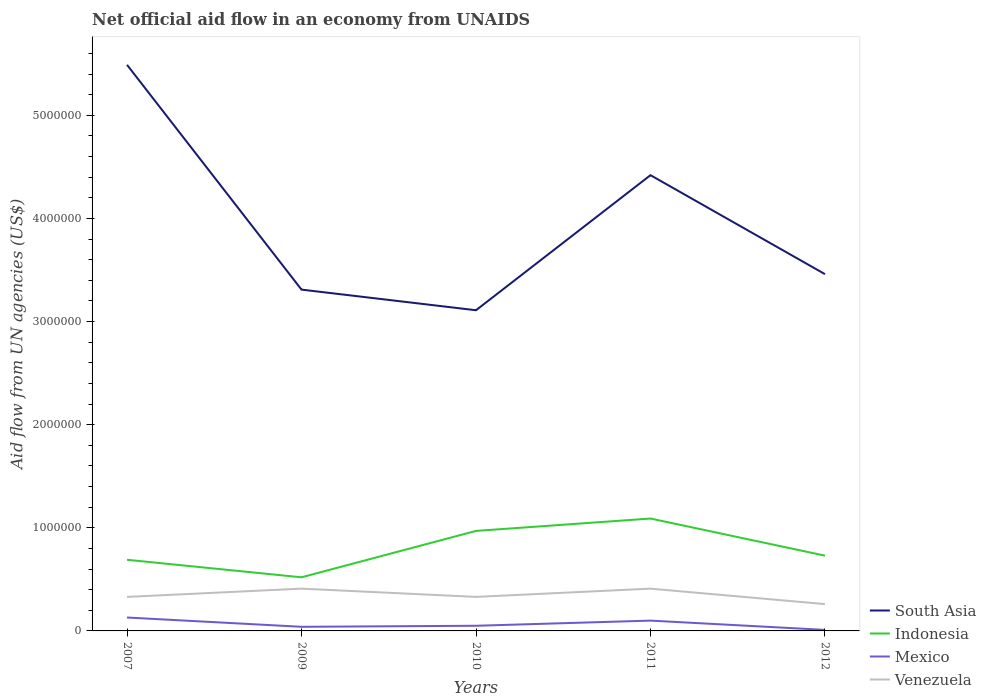How many different coloured lines are there?
Your response must be concise. 4. Is the number of lines equal to the number of legend labels?
Your response must be concise. Yes. Across all years, what is the maximum net official aid flow in Venezuela?
Your answer should be compact. 2.60e+05. In which year was the net official aid flow in South Asia maximum?
Your response must be concise. 2010. What is the difference between the highest and the second highest net official aid flow in South Asia?
Give a very brief answer. 2.38e+06. Is the net official aid flow in Indonesia strictly greater than the net official aid flow in South Asia over the years?
Give a very brief answer. Yes. How many lines are there?
Give a very brief answer. 4. What is the difference between two consecutive major ticks on the Y-axis?
Ensure brevity in your answer.  1.00e+06. Does the graph contain grids?
Offer a very short reply. No. How are the legend labels stacked?
Offer a very short reply. Vertical. What is the title of the graph?
Keep it short and to the point. Net official aid flow in an economy from UNAIDS. Does "Equatorial Guinea" appear as one of the legend labels in the graph?
Your answer should be compact. No. What is the label or title of the X-axis?
Ensure brevity in your answer.  Years. What is the label or title of the Y-axis?
Your answer should be compact. Aid flow from UN agencies (US$). What is the Aid flow from UN agencies (US$) in South Asia in 2007?
Offer a terse response. 5.49e+06. What is the Aid flow from UN agencies (US$) in Indonesia in 2007?
Make the answer very short. 6.90e+05. What is the Aid flow from UN agencies (US$) in Mexico in 2007?
Provide a succinct answer. 1.30e+05. What is the Aid flow from UN agencies (US$) of Venezuela in 2007?
Ensure brevity in your answer.  3.30e+05. What is the Aid flow from UN agencies (US$) in South Asia in 2009?
Make the answer very short. 3.31e+06. What is the Aid flow from UN agencies (US$) of Indonesia in 2009?
Offer a terse response. 5.20e+05. What is the Aid flow from UN agencies (US$) in South Asia in 2010?
Make the answer very short. 3.11e+06. What is the Aid flow from UN agencies (US$) of Indonesia in 2010?
Provide a short and direct response. 9.70e+05. What is the Aid flow from UN agencies (US$) in Mexico in 2010?
Provide a succinct answer. 5.00e+04. What is the Aid flow from UN agencies (US$) of South Asia in 2011?
Keep it short and to the point. 4.42e+06. What is the Aid flow from UN agencies (US$) of Indonesia in 2011?
Your answer should be very brief. 1.09e+06. What is the Aid flow from UN agencies (US$) of South Asia in 2012?
Ensure brevity in your answer.  3.46e+06. What is the Aid flow from UN agencies (US$) of Indonesia in 2012?
Ensure brevity in your answer.  7.30e+05. Across all years, what is the maximum Aid flow from UN agencies (US$) of South Asia?
Your answer should be very brief. 5.49e+06. Across all years, what is the maximum Aid flow from UN agencies (US$) of Indonesia?
Your response must be concise. 1.09e+06. Across all years, what is the maximum Aid flow from UN agencies (US$) of Mexico?
Provide a succinct answer. 1.30e+05. Across all years, what is the minimum Aid flow from UN agencies (US$) of South Asia?
Give a very brief answer. 3.11e+06. Across all years, what is the minimum Aid flow from UN agencies (US$) in Indonesia?
Make the answer very short. 5.20e+05. Across all years, what is the minimum Aid flow from UN agencies (US$) of Venezuela?
Ensure brevity in your answer.  2.60e+05. What is the total Aid flow from UN agencies (US$) of South Asia in the graph?
Your answer should be very brief. 1.98e+07. What is the total Aid flow from UN agencies (US$) in Venezuela in the graph?
Your answer should be compact. 1.74e+06. What is the difference between the Aid flow from UN agencies (US$) of South Asia in 2007 and that in 2009?
Keep it short and to the point. 2.18e+06. What is the difference between the Aid flow from UN agencies (US$) of Indonesia in 2007 and that in 2009?
Give a very brief answer. 1.70e+05. What is the difference between the Aid flow from UN agencies (US$) in Venezuela in 2007 and that in 2009?
Make the answer very short. -8.00e+04. What is the difference between the Aid flow from UN agencies (US$) of South Asia in 2007 and that in 2010?
Your answer should be very brief. 2.38e+06. What is the difference between the Aid flow from UN agencies (US$) in Indonesia in 2007 and that in 2010?
Make the answer very short. -2.80e+05. What is the difference between the Aid flow from UN agencies (US$) of Mexico in 2007 and that in 2010?
Ensure brevity in your answer.  8.00e+04. What is the difference between the Aid flow from UN agencies (US$) in Venezuela in 2007 and that in 2010?
Ensure brevity in your answer.  0. What is the difference between the Aid flow from UN agencies (US$) of South Asia in 2007 and that in 2011?
Your answer should be compact. 1.07e+06. What is the difference between the Aid flow from UN agencies (US$) in Indonesia in 2007 and that in 2011?
Your response must be concise. -4.00e+05. What is the difference between the Aid flow from UN agencies (US$) of Mexico in 2007 and that in 2011?
Give a very brief answer. 3.00e+04. What is the difference between the Aid flow from UN agencies (US$) of South Asia in 2007 and that in 2012?
Offer a very short reply. 2.03e+06. What is the difference between the Aid flow from UN agencies (US$) of Mexico in 2007 and that in 2012?
Offer a terse response. 1.20e+05. What is the difference between the Aid flow from UN agencies (US$) in Venezuela in 2007 and that in 2012?
Make the answer very short. 7.00e+04. What is the difference between the Aid flow from UN agencies (US$) in Indonesia in 2009 and that in 2010?
Give a very brief answer. -4.50e+05. What is the difference between the Aid flow from UN agencies (US$) of South Asia in 2009 and that in 2011?
Ensure brevity in your answer.  -1.11e+06. What is the difference between the Aid flow from UN agencies (US$) of Indonesia in 2009 and that in 2011?
Your answer should be very brief. -5.70e+05. What is the difference between the Aid flow from UN agencies (US$) in Mexico in 2009 and that in 2011?
Your answer should be compact. -6.00e+04. What is the difference between the Aid flow from UN agencies (US$) of Indonesia in 2009 and that in 2012?
Keep it short and to the point. -2.10e+05. What is the difference between the Aid flow from UN agencies (US$) in Mexico in 2009 and that in 2012?
Offer a very short reply. 3.00e+04. What is the difference between the Aid flow from UN agencies (US$) of Venezuela in 2009 and that in 2012?
Your response must be concise. 1.50e+05. What is the difference between the Aid flow from UN agencies (US$) in South Asia in 2010 and that in 2011?
Your response must be concise. -1.31e+06. What is the difference between the Aid flow from UN agencies (US$) in South Asia in 2010 and that in 2012?
Your answer should be very brief. -3.50e+05. What is the difference between the Aid flow from UN agencies (US$) in Indonesia in 2010 and that in 2012?
Your response must be concise. 2.40e+05. What is the difference between the Aid flow from UN agencies (US$) in Mexico in 2010 and that in 2012?
Provide a succinct answer. 4.00e+04. What is the difference between the Aid flow from UN agencies (US$) of South Asia in 2011 and that in 2012?
Offer a terse response. 9.60e+05. What is the difference between the Aid flow from UN agencies (US$) in Indonesia in 2011 and that in 2012?
Your response must be concise. 3.60e+05. What is the difference between the Aid flow from UN agencies (US$) in Mexico in 2011 and that in 2012?
Provide a succinct answer. 9.00e+04. What is the difference between the Aid flow from UN agencies (US$) of South Asia in 2007 and the Aid flow from UN agencies (US$) of Indonesia in 2009?
Your answer should be compact. 4.97e+06. What is the difference between the Aid flow from UN agencies (US$) of South Asia in 2007 and the Aid flow from UN agencies (US$) of Mexico in 2009?
Provide a succinct answer. 5.45e+06. What is the difference between the Aid flow from UN agencies (US$) of South Asia in 2007 and the Aid flow from UN agencies (US$) of Venezuela in 2009?
Ensure brevity in your answer.  5.08e+06. What is the difference between the Aid flow from UN agencies (US$) of Indonesia in 2007 and the Aid flow from UN agencies (US$) of Mexico in 2009?
Offer a very short reply. 6.50e+05. What is the difference between the Aid flow from UN agencies (US$) of Mexico in 2007 and the Aid flow from UN agencies (US$) of Venezuela in 2009?
Offer a very short reply. -2.80e+05. What is the difference between the Aid flow from UN agencies (US$) of South Asia in 2007 and the Aid flow from UN agencies (US$) of Indonesia in 2010?
Provide a short and direct response. 4.52e+06. What is the difference between the Aid flow from UN agencies (US$) in South Asia in 2007 and the Aid flow from UN agencies (US$) in Mexico in 2010?
Your answer should be compact. 5.44e+06. What is the difference between the Aid flow from UN agencies (US$) in South Asia in 2007 and the Aid flow from UN agencies (US$) in Venezuela in 2010?
Give a very brief answer. 5.16e+06. What is the difference between the Aid flow from UN agencies (US$) in Indonesia in 2007 and the Aid flow from UN agencies (US$) in Mexico in 2010?
Offer a terse response. 6.40e+05. What is the difference between the Aid flow from UN agencies (US$) of Mexico in 2007 and the Aid flow from UN agencies (US$) of Venezuela in 2010?
Offer a very short reply. -2.00e+05. What is the difference between the Aid flow from UN agencies (US$) in South Asia in 2007 and the Aid flow from UN agencies (US$) in Indonesia in 2011?
Ensure brevity in your answer.  4.40e+06. What is the difference between the Aid flow from UN agencies (US$) in South Asia in 2007 and the Aid flow from UN agencies (US$) in Mexico in 2011?
Ensure brevity in your answer.  5.39e+06. What is the difference between the Aid flow from UN agencies (US$) in South Asia in 2007 and the Aid flow from UN agencies (US$) in Venezuela in 2011?
Your response must be concise. 5.08e+06. What is the difference between the Aid flow from UN agencies (US$) in Indonesia in 2007 and the Aid flow from UN agencies (US$) in Mexico in 2011?
Keep it short and to the point. 5.90e+05. What is the difference between the Aid flow from UN agencies (US$) in Indonesia in 2007 and the Aid flow from UN agencies (US$) in Venezuela in 2011?
Offer a very short reply. 2.80e+05. What is the difference between the Aid flow from UN agencies (US$) of Mexico in 2007 and the Aid flow from UN agencies (US$) of Venezuela in 2011?
Make the answer very short. -2.80e+05. What is the difference between the Aid flow from UN agencies (US$) in South Asia in 2007 and the Aid flow from UN agencies (US$) in Indonesia in 2012?
Give a very brief answer. 4.76e+06. What is the difference between the Aid flow from UN agencies (US$) in South Asia in 2007 and the Aid flow from UN agencies (US$) in Mexico in 2012?
Keep it short and to the point. 5.48e+06. What is the difference between the Aid flow from UN agencies (US$) of South Asia in 2007 and the Aid flow from UN agencies (US$) of Venezuela in 2012?
Keep it short and to the point. 5.23e+06. What is the difference between the Aid flow from UN agencies (US$) in Indonesia in 2007 and the Aid flow from UN agencies (US$) in Mexico in 2012?
Keep it short and to the point. 6.80e+05. What is the difference between the Aid flow from UN agencies (US$) of Indonesia in 2007 and the Aid flow from UN agencies (US$) of Venezuela in 2012?
Your answer should be very brief. 4.30e+05. What is the difference between the Aid flow from UN agencies (US$) of Mexico in 2007 and the Aid flow from UN agencies (US$) of Venezuela in 2012?
Make the answer very short. -1.30e+05. What is the difference between the Aid flow from UN agencies (US$) of South Asia in 2009 and the Aid flow from UN agencies (US$) of Indonesia in 2010?
Keep it short and to the point. 2.34e+06. What is the difference between the Aid flow from UN agencies (US$) of South Asia in 2009 and the Aid flow from UN agencies (US$) of Mexico in 2010?
Your answer should be compact. 3.26e+06. What is the difference between the Aid flow from UN agencies (US$) of South Asia in 2009 and the Aid flow from UN agencies (US$) of Venezuela in 2010?
Your answer should be very brief. 2.98e+06. What is the difference between the Aid flow from UN agencies (US$) of Indonesia in 2009 and the Aid flow from UN agencies (US$) of Venezuela in 2010?
Offer a terse response. 1.90e+05. What is the difference between the Aid flow from UN agencies (US$) of Mexico in 2009 and the Aid flow from UN agencies (US$) of Venezuela in 2010?
Keep it short and to the point. -2.90e+05. What is the difference between the Aid flow from UN agencies (US$) of South Asia in 2009 and the Aid flow from UN agencies (US$) of Indonesia in 2011?
Keep it short and to the point. 2.22e+06. What is the difference between the Aid flow from UN agencies (US$) of South Asia in 2009 and the Aid flow from UN agencies (US$) of Mexico in 2011?
Offer a very short reply. 3.21e+06. What is the difference between the Aid flow from UN agencies (US$) in South Asia in 2009 and the Aid flow from UN agencies (US$) in Venezuela in 2011?
Give a very brief answer. 2.90e+06. What is the difference between the Aid flow from UN agencies (US$) of Indonesia in 2009 and the Aid flow from UN agencies (US$) of Mexico in 2011?
Provide a succinct answer. 4.20e+05. What is the difference between the Aid flow from UN agencies (US$) of Mexico in 2009 and the Aid flow from UN agencies (US$) of Venezuela in 2011?
Offer a very short reply. -3.70e+05. What is the difference between the Aid flow from UN agencies (US$) of South Asia in 2009 and the Aid flow from UN agencies (US$) of Indonesia in 2012?
Provide a succinct answer. 2.58e+06. What is the difference between the Aid flow from UN agencies (US$) of South Asia in 2009 and the Aid flow from UN agencies (US$) of Mexico in 2012?
Your answer should be compact. 3.30e+06. What is the difference between the Aid flow from UN agencies (US$) of South Asia in 2009 and the Aid flow from UN agencies (US$) of Venezuela in 2012?
Make the answer very short. 3.05e+06. What is the difference between the Aid flow from UN agencies (US$) in Indonesia in 2009 and the Aid flow from UN agencies (US$) in Mexico in 2012?
Make the answer very short. 5.10e+05. What is the difference between the Aid flow from UN agencies (US$) of Indonesia in 2009 and the Aid flow from UN agencies (US$) of Venezuela in 2012?
Provide a short and direct response. 2.60e+05. What is the difference between the Aid flow from UN agencies (US$) of Mexico in 2009 and the Aid flow from UN agencies (US$) of Venezuela in 2012?
Offer a very short reply. -2.20e+05. What is the difference between the Aid flow from UN agencies (US$) in South Asia in 2010 and the Aid flow from UN agencies (US$) in Indonesia in 2011?
Give a very brief answer. 2.02e+06. What is the difference between the Aid flow from UN agencies (US$) of South Asia in 2010 and the Aid flow from UN agencies (US$) of Mexico in 2011?
Offer a terse response. 3.01e+06. What is the difference between the Aid flow from UN agencies (US$) in South Asia in 2010 and the Aid flow from UN agencies (US$) in Venezuela in 2011?
Keep it short and to the point. 2.70e+06. What is the difference between the Aid flow from UN agencies (US$) in Indonesia in 2010 and the Aid flow from UN agencies (US$) in Mexico in 2011?
Keep it short and to the point. 8.70e+05. What is the difference between the Aid flow from UN agencies (US$) in Indonesia in 2010 and the Aid flow from UN agencies (US$) in Venezuela in 2011?
Offer a terse response. 5.60e+05. What is the difference between the Aid flow from UN agencies (US$) in Mexico in 2010 and the Aid flow from UN agencies (US$) in Venezuela in 2011?
Ensure brevity in your answer.  -3.60e+05. What is the difference between the Aid flow from UN agencies (US$) of South Asia in 2010 and the Aid flow from UN agencies (US$) of Indonesia in 2012?
Give a very brief answer. 2.38e+06. What is the difference between the Aid flow from UN agencies (US$) in South Asia in 2010 and the Aid flow from UN agencies (US$) in Mexico in 2012?
Provide a succinct answer. 3.10e+06. What is the difference between the Aid flow from UN agencies (US$) in South Asia in 2010 and the Aid flow from UN agencies (US$) in Venezuela in 2012?
Make the answer very short. 2.85e+06. What is the difference between the Aid flow from UN agencies (US$) in Indonesia in 2010 and the Aid flow from UN agencies (US$) in Mexico in 2012?
Provide a succinct answer. 9.60e+05. What is the difference between the Aid flow from UN agencies (US$) of Indonesia in 2010 and the Aid flow from UN agencies (US$) of Venezuela in 2012?
Give a very brief answer. 7.10e+05. What is the difference between the Aid flow from UN agencies (US$) in Mexico in 2010 and the Aid flow from UN agencies (US$) in Venezuela in 2012?
Give a very brief answer. -2.10e+05. What is the difference between the Aid flow from UN agencies (US$) of South Asia in 2011 and the Aid flow from UN agencies (US$) of Indonesia in 2012?
Your response must be concise. 3.69e+06. What is the difference between the Aid flow from UN agencies (US$) of South Asia in 2011 and the Aid flow from UN agencies (US$) of Mexico in 2012?
Provide a succinct answer. 4.41e+06. What is the difference between the Aid flow from UN agencies (US$) in South Asia in 2011 and the Aid flow from UN agencies (US$) in Venezuela in 2012?
Keep it short and to the point. 4.16e+06. What is the difference between the Aid flow from UN agencies (US$) in Indonesia in 2011 and the Aid flow from UN agencies (US$) in Mexico in 2012?
Make the answer very short. 1.08e+06. What is the difference between the Aid flow from UN agencies (US$) of Indonesia in 2011 and the Aid flow from UN agencies (US$) of Venezuela in 2012?
Ensure brevity in your answer.  8.30e+05. What is the average Aid flow from UN agencies (US$) in South Asia per year?
Give a very brief answer. 3.96e+06. What is the average Aid flow from UN agencies (US$) of Indonesia per year?
Your answer should be compact. 8.00e+05. What is the average Aid flow from UN agencies (US$) in Mexico per year?
Keep it short and to the point. 6.60e+04. What is the average Aid flow from UN agencies (US$) of Venezuela per year?
Offer a very short reply. 3.48e+05. In the year 2007, what is the difference between the Aid flow from UN agencies (US$) of South Asia and Aid flow from UN agencies (US$) of Indonesia?
Make the answer very short. 4.80e+06. In the year 2007, what is the difference between the Aid flow from UN agencies (US$) of South Asia and Aid flow from UN agencies (US$) of Mexico?
Ensure brevity in your answer.  5.36e+06. In the year 2007, what is the difference between the Aid flow from UN agencies (US$) in South Asia and Aid flow from UN agencies (US$) in Venezuela?
Ensure brevity in your answer.  5.16e+06. In the year 2007, what is the difference between the Aid flow from UN agencies (US$) of Indonesia and Aid flow from UN agencies (US$) of Mexico?
Provide a short and direct response. 5.60e+05. In the year 2007, what is the difference between the Aid flow from UN agencies (US$) in Indonesia and Aid flow from UN agencies (US$) in Venezuela?
Your answer should be very brief. 3.60e+05. In the year 2009, what is the difference between the Aid flow from UN agencies (US$) of South Asia and Aid flow from UN agencies (US$) of Indonesia?
Make the answer very short. 2.79e+06. In the year 2009, what is the difference between the Aid flow from UN agencies (US$) in South Asia and Aid flow from UN agencies (US$) in Mexico?
Provide a short and direct response. 3.27e+06. In the year 2009, what is the difference between the Aid flow from UN agencies (US$) of South Asia and Aid flow from UN agencies (US$) of Venezuela?
Ensure brevity in your answer.  2.90e+06. In the year 2009, what is the difference between the Aid flow from UN agencies (US$) in Indonesia and Aid flow from UN agencies (US$) in Mexico?
Your answer should be very brief. 4.80e+05. In the year 2009, what is the difference between the Aid flow from UN agencies (US$) in Mexico and Aid flow from UN agencies (US$) in Venezuela?
Keep it short and to the point. -3.70e+05. In the year 2010, what is the difference between the Aid flow from UN agencies (US$) of South Asia and Aid flow from UN agencies (US$) of Indonesia?
Ensure brevity in your answer.  2.14e+06. In the year 2010, what is the difference between the Aid flow from UN agencies (US$) of South Asia and Aid flow from UN agencies (US$) of Mexico?
Ensure brevity in your answer.  3.06e+06. In the year 2010, what is the difference between the Aid flow from UN agencies (US$) in South Asia and Aid flow from UN agencies (US$) in Venezuela?
Provide a short and direct response. 2.78e+06. In the year 2010, what is the difference between the Aid flow from UN agencies (US$) in Indonesia and Aid flow from UN agencies (US$) in Mexico?
Your response must be concise. 9.20e+05. In the year 2010, what is the difference between the Aid flow from UN agencies (US$) in Indonesia and Aid flow from UN agencies (US$) in Venezuela?
Make the answer very short. 6.40e+05. In the year 2010, what is the difference between the Aid flow from UN agencies (US$) of Mexico and Aid flow from UN agencies (US$) of Venezuela?
Provide a succinct answer. -2.80e+05. In the year 2011, what is the difference between the Aid flow from UN agencies (US$) of South Asia and Aid flow from UN agencies (US$) of Indonesia?
Give a very brief answer. 3.33e+06. In the year 2011, what is the difference between the Aid flow from UN agencies (US$) of South Asia and Aid flow from UN agencies (US$) of Mexico?
Keep it short and to the point. 4.32e+06. In the year 2011, what is the difference between the Aid flow from UN agencies (US$) of South Asia and Aid flow from UN agencies (US$) of Venezuela?
Offer a very short reply. 4.01e+06. In the year 2011, what is the difference between the Aid flow from UN agencies (US$) of Indonesia and Aid flow from UN agencies (US$) of Mexico?
Offer a terse response. 9.90e+05. In the year 2011, what is the difference between the Aid flow from UN agencies (US$) of Indonesia and Aid flow from UN agencies (US$) of Venezuela?
Make the answer very short. 6.80e+05. In the year 2011, what is the difference between the Aid flow from UN agencies (US$) of Mexico and Aid flow from UN agencies (US$) of Venezuela?
Your answer should be very brief. -3.10e+05. In the year 2012, what is the difference between the Aid flow from UN agencies (US$) in South Asia and Aid flow from UN agencies (US$) in Indonesia?
Provide a succinct answer. 2.73e+06. In the year 2012, what is the difference between the Aid flow from UN agencies (US$) of South Asia and Aid flow from UN agencies (US$) of Mexico?
Keep it short and to the point. 3.45e+06. In the year 2012, what is the difference between the Aid flow from UN agencies (US$) of South Asia and Aid flow from UN agencies (US$) of Venezuela?
Ensure brevity in your answer.  3.20e+06. In the year 2012, what is the difference between the Aid flow from UN agencies (US$) in Indonesia and Aid flow from UN agencies (US$) in Mexico?
Provide a short and direct response. 7.20e+05. What is the ratio of the Aid flow from UN agencies (US$) in South Asia in 2007 to that in 2009?
Provide a succinct answer. 1.66. What is the ratio of the Aid flow from UN agencies (US$) in Indonesia in 2007 to that in 2009?
Keep it short and to the point. 1.33. What is the ratio of the Aid flow from UN agencies (US$) of Mexico in 2007 to that in 2009?
Provide a succinct answer. 3.25. What is the ratio of the Aid flow from UN agencies (US$) of Venezuela in 2007 to that in 2009?
Make the answer very short. 0.8. What is the ratio of the Aid flow from UN agencies (US$) in South Asia in 2007 to that in 2010?
Your response must be concise. 1.77. What is the ratio of the Aid flow from UN agencies (US$) of Indonesia in 2007 to that in 2010?
Your response must be concise. 0.71. What is the ratio of the Aid flow from UN agencies (US$) in South Asia in 2007 to that in 2011?
Keep it short and to the point. 1.24. What is the ratio of the Aid flow from UN agencies (US$) of Indonesia in 2007 to that in 2011?
Your response must be concise. 0.63. What is the ratio of the Aid flow from UN agencies (US$) of Venezuela in 2007 to that in 2011?
Offer a terse response. 0.8. What is the ratio of the Aid flow from UN agencies (US$) in South Asia in 2007 to that in 2012?
Make the answer very short. 1.59. What is the ratio of the Aid flow from UN agencies (US$) of Indonesia in 2007 to that in 2012?
Make the answer very short. 0.95. What is the ratio of the Aid flow from UN agencies (US$) of Mexico in 2007 to that in 2012?
Keep it short and to the point. 13. What is the ratio of the Aid flow from UN agencies (US$) of Venezuela in 2007 to that in 2012?
Provide a short and direct response. 1.27. What is the ratio of the Aid flow from UN agencies (US$) in South Asia in 2009 to that in 2010?
Your response must be concise. 1.06. What is the ratio of the Aid flow from UN agencies (US$) in Indonesia in 2009 to that in 2010?
Provide a short and direct response. 0.54. What is the ratio of the Aid flow from UN agencies (US$) of Mexico in 2009 to that in 2010?
Your answer should be compact. 0.8. What is the ratio of the Aid flow from UN agencies (US$) of Venezuela in 2009 to that in 2010?
Offer a terse response. 1.24. What is the ratio of the Aid flow from UN agencies (US$) in South Asia in 2009 to that in 2011?
Ensure brevity in your answer.  0.75. What is the ratio of the Aid flow from UN agencies (US$) of Indonesia in 2009 to that in 2011?
Provide a short and direct response. 0.48. What is the ratio of the Aid flow from UN agencies (US$) in Venezuela in 2009 to that in 2011?
Ensure brevity in your answer.  1. What is the ratio of the Aid flow from UN agencies (US$) in South Asia in 2009 to that in 2012?
Keep it short and to the point. 0.96. What is the ratio of the Aid flow from UN agencies (US$) of Indonesia in 2009 to that in 2012?
Make the answer very short. 0.71. What is the ratio of the Aid flow from UN agencies (US$) in Mexico in 2009 to that in 2012?
Ensure brevity in your answer.  4. What is the ratio of the Aid flow from UN agencies (US$) of Venezuela in 2009 to that in 2012?
Provide a short and direct response. 1.58. What is the ratio of the Aid flow from UN agencies (US$) in South Asia in 2010 to that in 2011?
Your answer should be very brief. 0.7. What is the ratio of the Aid flow from UN agencies (US$) in Indonesia in 2010 to that in 2011?
Your answer should be very brief. 0.89. What is the ratio of the Aid flow from UN agencies (US$) of Venezuela in 2010 to that in 2011?
Make the answer very short. 0.8. What is the ratio of the Aid flow from UN agencies (US$) of South Asia in 2010 to that in 2012?
Offer a very short reply. 0.9. What is the ratio of the Aid flow from UN agencies (US$) in Indonesia in 2010 to that in 2012?
Ensure brevity in your answer.  1.33. What is the ratio of the Aid flow from UN agencies (US$) in Mexico in 2010 to that in 2012?
Your answer should be very brief. 5. What is the ratio of the Aid flow from UN agencies (US$) of Venezuela in 2010 to that in 2012?
Your answer should be compact. 1.27. What is the ratio of the Aid flow from UN agencies (US$) of South Asia in 2011 to that in 2012?
Ensure brevity in your answer.  1.28. What is the ratio of the Aid flow from UN agencies (US$) of Indonesia in 2011 to that in 2012?
Make the answer very short. 1.49. What is the ratio of the Aid flow from UN agencies (US$) in Mexico in 2011 to that in 2012?
Provide a short and direct response. 10. What is the ratio of the Aid flow from UN agencies (US$) in Venezuela in 2011 to that in 2012?
Give a very brief answer. 1.58. What is the difference between the highest and the second highest Aid flow from UN agencies (US$) of South Asia?
Keep it short and to the point. 1.07e+06. What is the difference between the highest and the second highest Aid flow from UN agencies (US$) of Mexico?
Your answer should be very brief. 3.00e+04. What is the difference between the highest and the lowest Aid flow from UN agencies (US$) in South Asia?
Make the answer very short. 2.38e+06. What is the difference between the highest and the lowest Aid flow from UN agencies (US$) in Indonesia?
Your response must be concise. 5.70e+05. What is the difference between the highest and the lowest Aid flow from UN agencies (US$) in Venezuela?
Your answer should be compact. 1.50e+05. 